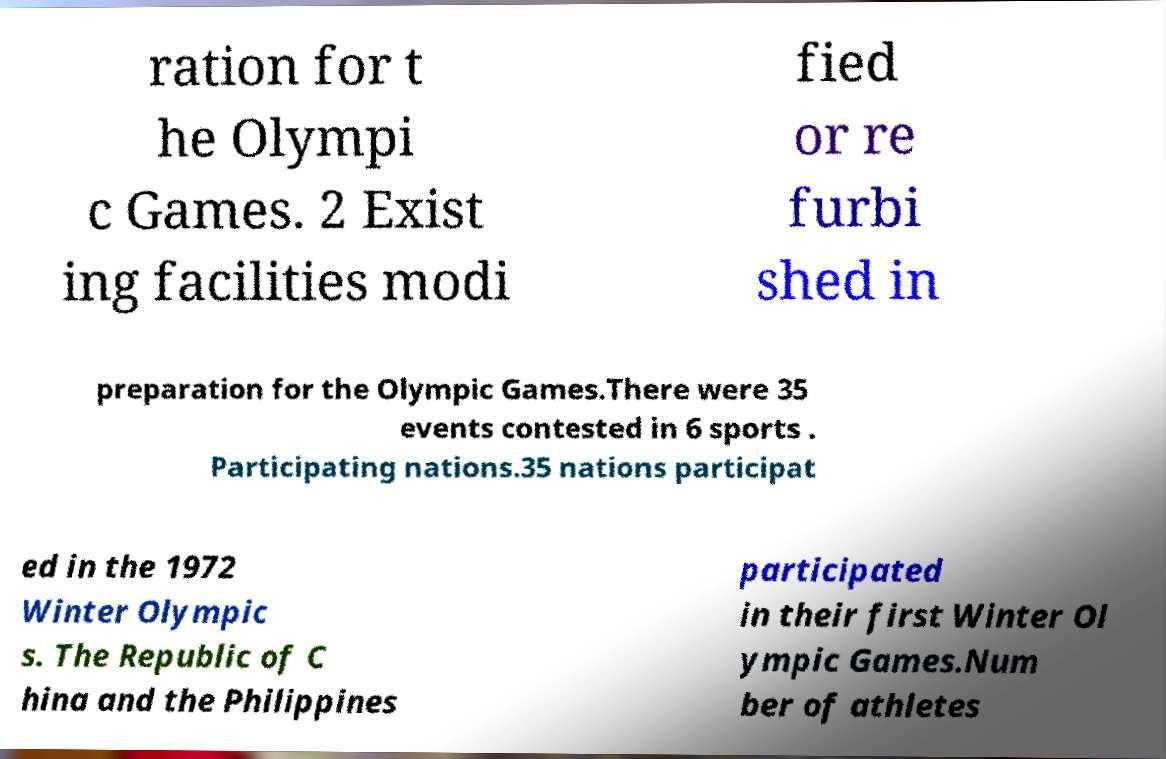Please identify and transcribe the text found in this image. ration for t he Olympi c Games. 2 Exist ing facilities modi fied or re furbi shed in preparation for the Olympic Games.There were 35 events contested in 6 sports . Participating nations.35 nations participat ed in the 1972 Winter Olympic s. The Republic of C hina and the Philippines participated in their first Winter Ol ympic Games.Num ber of athletes 